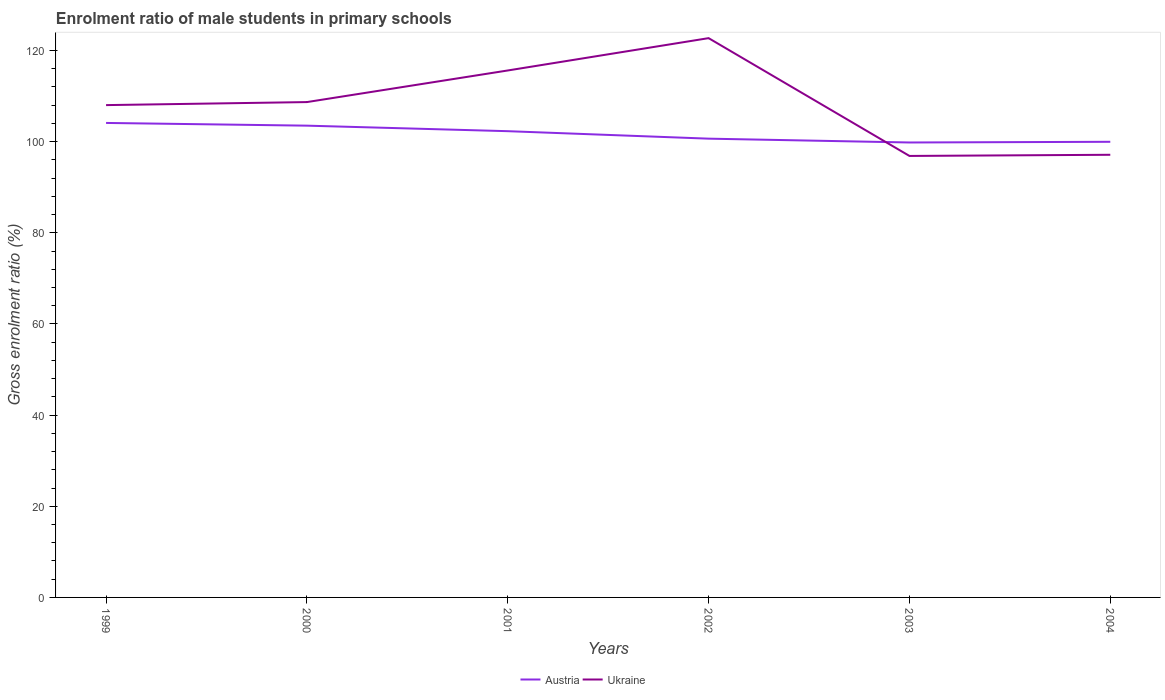How many different coloured lines are there?
Your response must be concise. 2. Does the line corresponding to Ukraine intersect with the line corresponding to Austria?
Provide a short and direct response. Yes. Across all years, what is the maximum enrolment ratio of male students in primary schools in Austria?
Offer a terse response. 99.81. What is the total enrolment ratio of male students in primary schools in Ukraine in the graph?
Your response must be concise. 11.15. What is the difference between the highest and the second highest enrolment ratio of male students in primary schools in Austria?
Provide a succinct answer. 4.29. What is the difference between the highest and the lowest enrolment ratio of male students in primary schools in Ukraine?
Make the answer very short. 3. Is the enrolment ratio of male students in primary schools in Ukraine strictly greater than the enrolment ratio of male students in primary schools in Austria over the years?
Your answer should be very brief. No. What is the difference between two consecutive major ticks on the Y-axis?
Offer a terse response. 20. Does the graph contain any zero values?
Provide a short and direct response. No. Does the graph contain grids?
Your response must be concise. No. What is the title of the graph?
Offer a very short reply. Enrolment ratio of male students in primary schools. What is the label or title of the X-axis?
Your answer should be compact. Years. What is the Gross enrolment ratio (%) in Austria in 1999?
Keep it short and to the point. 104.1. What is the Gross enrolment ratio (%) of Ukraine in 1999?
Give a very brief answer. 108.01. What is the Gross enrolment ratio (%) of Austria in 2000?
Your answer should be very brief. 103.5. What is the Gross enrolment ratio (%) in Ukraine in 2000?
Make the answer very short. 108.67. What is the Gross enrolment ratio (%) in Austria in 2001?
Your answer should be compact. 102.29. What is the Gross enrolment ratio (%) of Ukraine in 2001?
Offer a terse response. 115.6. What is the Gross enrolment ratio (%) in Austria in 2002?
Ensure brevity in your answer.  100.65. What is the Gross enrolment ratio (%) of Ukraine in 2002?
Give a very brief answer. 122.7. What is the Gross enrolment ratio (%) of Austria in 2003?
Offer a terse response. 99.81. What is the Gross enrolment ratio (%) in Ukraine in 2003?
Your answer should be very brief. 96.86. What is the Gross enrolment ratio (%) of Austria in 2004?
Provide a succinct answer. 99.96. What is the Gross enrolment ratio (%) in Ukraine in 2004?
Provide a short and direct response. 97.11. Across all years, what is the maximum Gross enrolment ratio (%) in Austria?
Make the answer very short. 104.1. Across all years, what is the maximum Gross enrolment ratio (%) of Ukraine?
Keep it short and to the point. 122.7. Across all years, what is the minimum Gross enrolment ratio (%) of Austria?
Provide a succinct answer. 99.81. Across all years, what is the minimum Gross enrolment ratio (%) of Ukraine?
Your answer should be compact. 96.86. What is the total Gross enrolment ratio (%) in Austria in the graph?
Your answer should be very brief. 610.29. What is the total Gross enrolment ratio (%) in Ukraine in the graph?
Your answer should be compact. 648.95. What is the difference between the Gross enrolment ratio (%) of Austria in 1999 and that in 2000?
Your response must be concise. 0.6. What is the difference between the Gross enrolment ratio (%) of Ukraine in 1999 and that in 2000?
Your answer should be compact. -0.66. What is the difference between the Gross enrolment ratio (%) in Austria in 1999 and that in 2001?
Provide a succinct answer. 1.81. What is the difference between the Gross enrolment ratio (%) in Ukraine in 1999 and that in 2001?
Your response must be concise. -7.6. What is the difference between the Gross enrolment ratio (%) in Austria in 1999 and that in 2002?
Make the answer very short. 3.45. What is the difference between the Gross enrolment ratio (%) of Ukraine in 1999 and that in 2002?
Your answer should be very brief. -14.69. What is the difference between the Gross enrolment ratio (%) in Austria in 1999 and that in 2003?
Make the answer very short. 4.29. What is the difference between the Gross enrolment ratio (%) of Ukraine in 1999 and that in 2003?
Your answer should be compact. 11.15. What is the difference between the Gross enrolment ratio (%) of Austria in 1999 and that in 2004?
Your answer should be compact. 4.14. What is the difference between the Gross enrolment ratio (%) in Ukraine in 1999 and that in 2004?
Your response must be concise. 10.9. What is the difference between the Gross enrolment ratio (%) in Austria in 2000 and that in 2001?
Keep it short and to the point. 1.21. What is the difference between the Gross enrolment ratio (%) in Ukraine in 2000 and that in 2001?
Keep it short and to the point. -6.93. What is the difference between the Gross enrolment ratio (%) in Austria in 2000 and that in 2002?
Provide a short and direct response. 2.85. What is the difference between the Gross enrolment ratio (%) in Ukraine in 2000 and that in 2002?
Ensure brevity in your answer.  -14.03. What is the difference between the Gross enrolment ratio (%) of Austria in 2000 and that in 2003?
Give a very brief answer. 3.69. What is the difference between the Gross enrolment ratio (%) of Ukraine in 2000 and that in 2003?
Offer a terse response. 11.81. What is the difference between the Gross enrolment ratio (%) of Austria in 2000 and that in 2004?
Provide a short and direct response. 3.54. What is the difference between the Gross enrolment ratio (%) of Ukraine in 2000 and that in 2004?
Your response must be concise. 11.56. What is the difference between the Gross enrolment ratio (%) of Austria in 2001 and that in 2002?
Give a very brief answer. 1.64. What is the difference between the Gross enrolment ratio (%) of Ukraine in 2001 and that in 2002?
Keep it short and to the point. -7.09. What is the difference between the Gross enrolment ratio (%) in Austria in 2001 and that in 2003?
Keep it short and to the point. 2.48. What is the difference between the Gross enrolment ratio (%) of Ukraine in 2001 and that in 2003?
Provide a short and direct response. 18.75. What is the difference between the Gross enrolment ratio (%) of Austria in 2001 and that in 2004?
Your answer should be compact. 2.33. What is the difference between the Gross enrolment ratio (%) in Ukraine in 2001 and that in 2004?
Provide a succinct answer. 18.49. What is the difference between the Gross enrolment ratio (%) of Austria in 2002 and that in 2003?
Your answer should be very brief. 0.84. What is the difference between the Gross enrolment ratio (%) in Ukraine in 2002 and that in 2003?
Keep it short and to the point. 25.84. What is the difference between the Gross enrolment ratio (%) in Austria in 2002 and that in 2004?
Your response must be concise. 0.69. What is the difference between the Gross enrolment ratio (%) of Ukraine in 2002 and that in 2004?
Ensure brevity in your answer.  25.59. What is the difference between the Gross enrolment ratio (%) in Austria in 2003 and that in 2004?
Keep it short and to the point. -0.15. What is the difference between the Gross enrolment ratio (%) of Ukraine in 2003 and that in 2004?
Give a very brief answer. -0.25. What is the difference between the Gross enrolment ratio (%) of Austria in 1999 and the Gross enrolment ratio (%) of Ukraine in 2000?
Ensure brevity in your answer.  -4.57. What is the difference between the Gross enrolment ratio (%) of Austria in 1999 and the Gross enrolment ratio (%) of Ukraine in 2001?
Offer a terse response. -11.51. What is the difference between the Gross enrolment ratio (%) in Austria in 1999 and the Gross enrolment ratio (%) in Ukraine in 2002?
Make the answer very short. -18.6. What is the difference between the Gross enrolment ratio (%) in Austria in 1999 and the Gross enrolment ratio (%) in Ukraine in 2003?
Offer a terse response. 7.24. What is the difference between the Gross enrolment ratio (%) of Austria in 1999 and the Gross enrolment ratio (%) of Ukraine in 2004?
Your answer should be compact. 6.99. What is the difference between the Gross enrolment ratio (%) in Austria in 2000 and the Gross enrolment ratio (%) in Ukraine in 2001?
Provide a short and direct response. -12.1. What is the difference between the Gross enrolment ratio (%) in Austria in 2000 and the Gross enrolment ratio (%) in Ukraine in 2002?
Your answer should be very brief. -19.2. What is the difference between the Gross enrolment ratio (%) in Austria in 2000 and the Gross enrolment ratio (%) in Ukraine in 2003?
Provide a succinct answer. 6.64. What is the difference between the Gross enrolment ratio (%) in Austria in 2000 and the Gross enrolment ratio (%) in Ukraine in 2004?
Offer a very short reply. 6.39. What is the difference between the Gross enrolment ratio (%) of Austria in 2001 and the Gross enrolment ratio (%) of Ukraine in 2002?
Provide a short and direct response. -20.41. What is the difference between the Gross enrolment ratio (%) of Austria in 2001 and the Gross enrolment ratio (%) of Ukraine in 2003?
Your answer should be very brief. 5.43. What is the difference between the Gross enrolment ratio (%) of Austria in 2001 and the Gross enrolment ratio (%) of Ukraine in 2004?
Make the answer very short. 5.18. What is the difference between the Gross enrolment ratio (%) of Austria in 2002 and the Gross enrolment ratio (%) of Ukraine in 2003?
Your response must be concise. 3.79. What is the difference between the Gross enrolment ratio (%) in Austria in 2002 and the Gross enrolment ratio (%) in Ukraine in 2004?
Offer a terse response. 3.54. What is the difference between the Gross enrolment ratio (%) of Austria in 2003 and the Gross enrolment ratio (%) of Ukraine in 2004?
Your response must be concise. 2.7. What is the average Gross enrolment ratio (%) of Austria per year?
Your answer should be compact. 101.72. What is the average Gross enrolment ratio (%) of Ukraine per year?
Keep it short and to the point. 108.16. In the year 1999, what is the difference between the Gross enrolment ratio (%) in Austria and Gross enrolment ratio (%) in Ukraine?
Ensure brevity in your answer.  -3.91. In the year 2000, what is the difference between the Gross enrolment ratio (%) in Austria and Gross enrolment ratio (%) in Ukraine?
Offer a very short reply. -5.17. In the year 2001, what is the difference between the Gross enrolment ratio (%) in Austria and Gross enrolment ratio (%) in Ukraine?
Give a very brief answer. -13.32. In the year 2002, what is the difference between the Gross enrolment ratio (%) of Austria and Gross enrolment ratio (%) of Ukraine?
Your answer should be very brief. -22.05. In the year 2003, what is the difference between the Gross enrolment ratio (%) in Austria and Gross enrolment ratio (%) in Ukraine?
Your answer should be very brief. 2.95. In the year 2004, what is the difference between the Gross enrolment ratio (%) of Austria and Gross enrolment ratio (%) of Ukraine?
Ensure brevity in your answer.  2.85. What is the ratio of the Gross enrolment ratio (%) of Austria in 1999 to that in 2000?
Offer a terse response. 1.01. What is the ratio of the Gross enrolment ratio (%) of Ukraine in 1999 to that in 2000?
Offer a very short reply. 0.99. What is the ratio of the Gross enrolment ratio (%) of Austria in 1999 to that in 2001?
Provide a short and direct response. 1.02. What is the ratio of the Gross enrolment ratio (%) of Ukraine in 1999 to that in 2001?
Keep it short and to the point. 0.93. What is the ratio of the Gross enrolment ratio (%) in Austria in 1999 to that in 2002?
Your answer should be very brief. 1.03. What is the ratio of the Gross enrolment ratio (%) in Ukraine in 1999 to that in 2002?
Provide a succinct answer. 0.88. What is the ratio of the Gross enrolment ratio (%) of Austria in 1999 to that in 2003?
Your response must be concise. 1.04. What is the ratio of the Gross enrolment ratio (%) of Ukraine in 1999 to that in 2003?
Your answer should be very brief. 1.12. What is the ratio of the Gross enrolment ratio (%) of Austria in 1999 to that in 2004?
Your answer should be very brief. 1.04. What is the ratio of the Gross enrolment ratio (%) in Ukraine in 1999 to that in 2004?
Your response must be concise. 1.11. What is the ratio of the Gross enrolment ratio (%) in Austria in 2000 to that in 2001?
Keep it short and to the point. 1.01. What is the ratio of the Gross enrolment ratio (%) in Austria in 2000 to that in 2002?
Your answer should be very brief. 1.03. What is the ratio of the Gross enrolment ratio (%) of Ukraine in 2000 to that in 2002?
Your answer should be very brief. 0.89. What is the ratio of the Gross enrolment ratio (%) of Austria in 2000 to that in 2003?
Ensure brevity in your answer.  1.04. What is the ratio of the Gross enrolment ratio (%) of Ukraine in 2000 to that in 2003?
Keep it short and to the point. 1.12. What is the ratio of the Gross enrolment ratio (%) in Austria in 2000 to that in 2004?
Give a very brief answer. 1.04. What is the ratio of the Gross enrolment ratio (%) of Ukraine in 2000 to that in 2004?
Your answer should be compact. 1.12. What is the ratio of the Gross enrolment ratio (%) of Austria in 2001 to that in 2002?
Make the answer very short. 1.02. What is the ratio of the Gross enrolment ratio (%) of Ukraine in 2001 to that in 2002?
Your response must be concise. 0.94. What is the ratio of the Gross enrolment ratio (%) of Austria in 2001 to that in 2003?
Provide a short and direct response. 1.02. What is the ratio of the Gross enrolment ratio (%) of Ukraine in 2001 to that in 2003?
Offer a very short reply. 1.19. What is the ratio of the Gross enrolment ratio (%) in Austria in 2001 to that in 2004?
Offer a terse response. 1.02. What is the ratio of the Gross enrolment ratio (%) of Ukraine in 2001 to that in 2004?
Your answer should be very brief. 1.19. What is the ratio of the Gross enrolment ratio (%) of Austria in 2002 to that in 2003?
Offer a very short reply. 1.01. What is the ratio of the Gross enrolment ratio (%) of Ukraine in 2002 to that in 2003?
Give a very brief answer. 1.27. What is the ratio of the Gross enrolment ratio (%) in Ukraine in 2002 to that in 2004?
Make the answer very short. 1.26. What is the ratio of the Gross enrolment ratio (%) in Austria in 2003 to that in 2004?
Your answer should be very brief. 1. What is the ratio of the Gross enrolment ratio (%) of Ukraine in 2003 to that in 2004?
Your response must be concise. 1. What is the difference between the highest and the second highest Gross enrolment ratio (%) of Austria?
Your response must be concise. 0.6. What is the difference between the highest and the second highest Gross enrolment ratio (%) of Ukraine?
Your response must be concise. 7.09. What is the difference between the highest and the lowest Gross enrolment ratio (%) in Austria?
Your answer should be very brief. 4.29. What is the difference between the highest and the lowest Gross enrolment ratio (%) of Ukraine?
Keep it short and to the point. 25.84. 